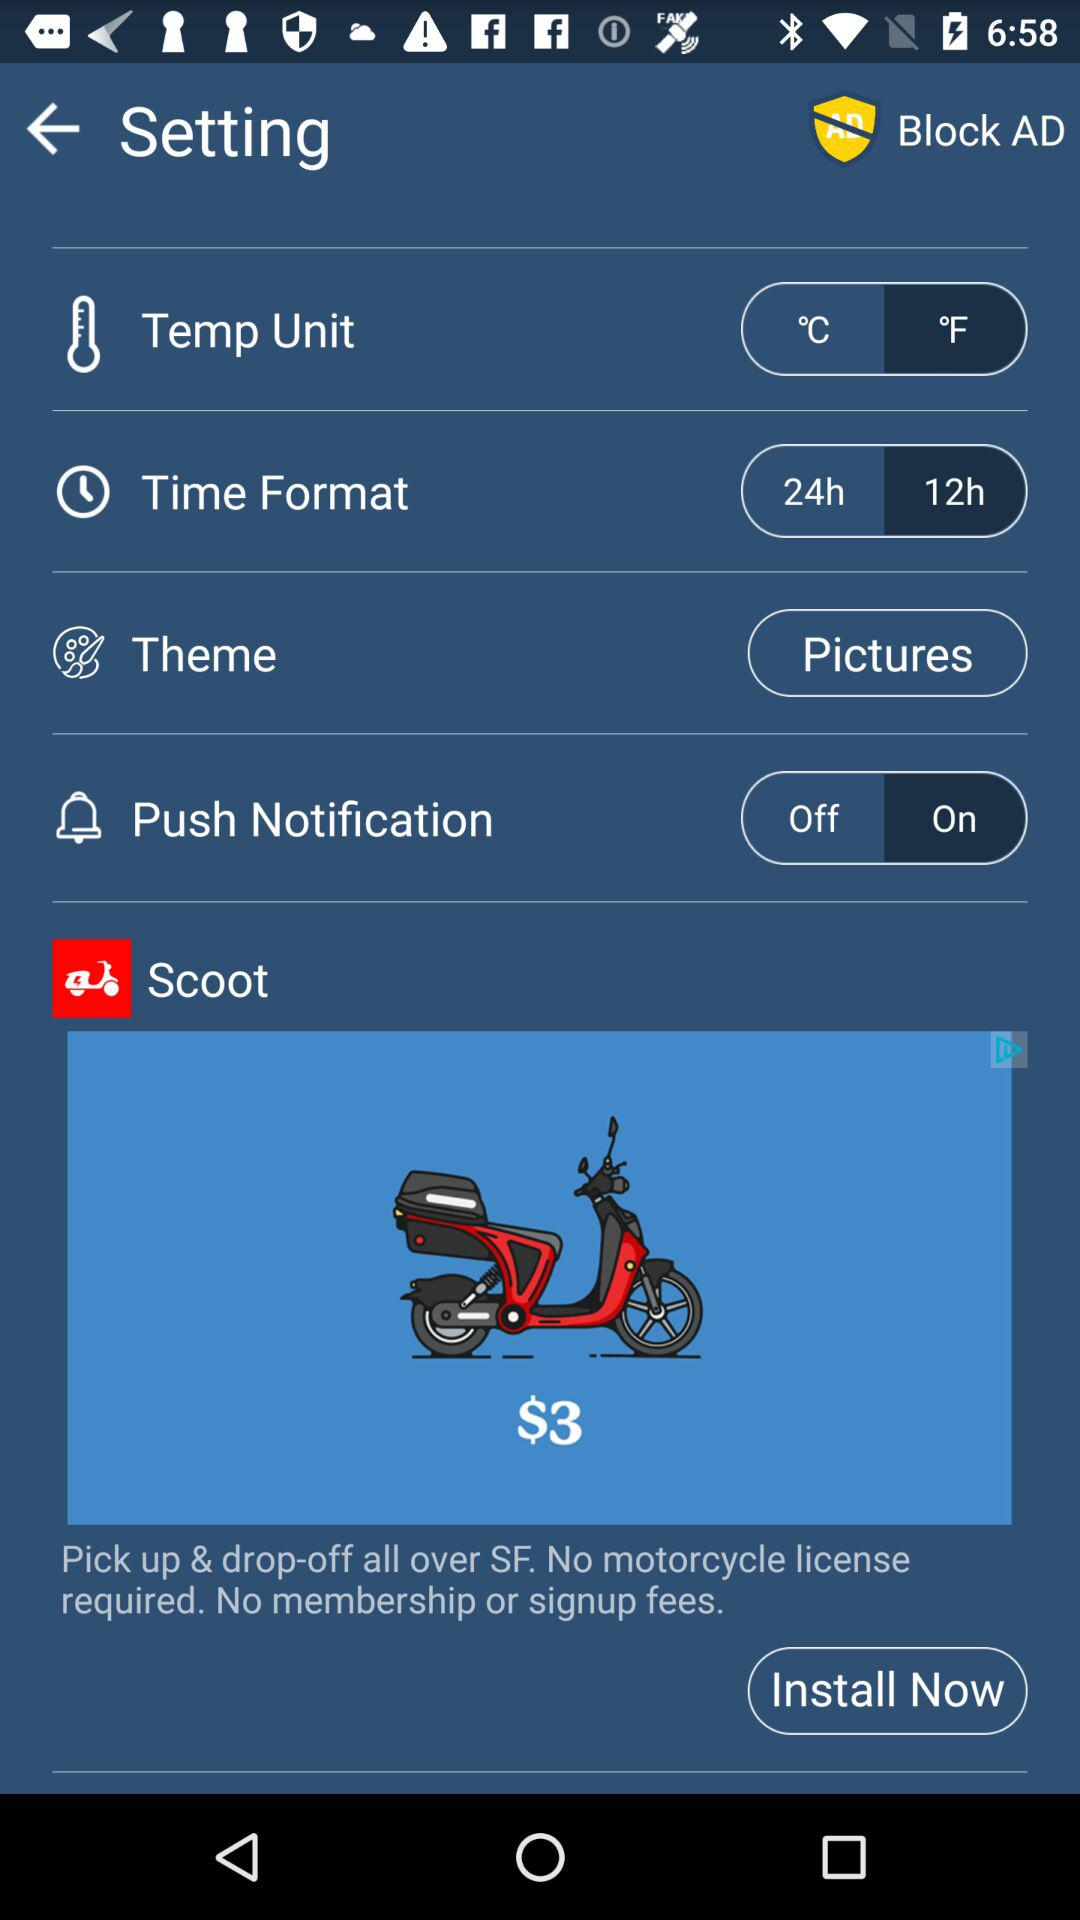What is the status of "Push Notification"? The status of "Push Notification" is "on". 